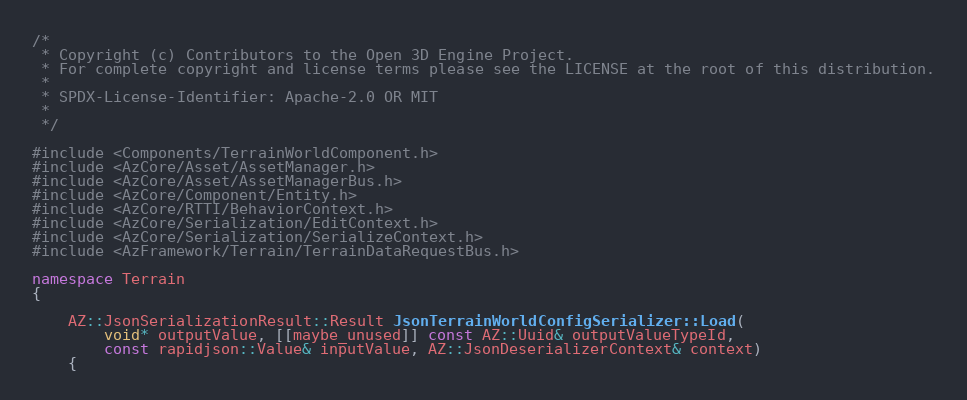Convert code to text. <code><loc_0><loc_0><loc_500><loc_500><_C++_>/*
 * Copyright (c) Contributors to the Open 3D Engine Project.
 * For complete copyright and license terms please see the LICENSE at the root of this distribution.
 *
 * SPDX-License-Identifier: Apache-2.0 OR MIT
 *
 */

#include <Components/TerrainWorldComponent.h>
#include <AzCore/Asset/AssetManager.h>
#include <AzCore/Asset/AssetManagerBus.h>
#include <AzCore/Component/Entity.h>
#include <AzCore/RTTI/BehaviorContext.h>
#include <AzCore/Serialization/EditContext.h>
#include <AzCore/Serialization/SerializeContext.h>
#include <AzFramework/Terrain/TerrainDataRequestBus.h>

namespace Terrain
{
    
    AZ::JsonSerializationResult::Result JsonTerrainWorldConfigSerializer::Load(
        void* outputValue, [[maybe_unused]] const AZ::Uuid& outputValueTypeId,
        const rapidjson::Value& inputValue, AZ::JsonDeserializerContext& context)
    {</code> 